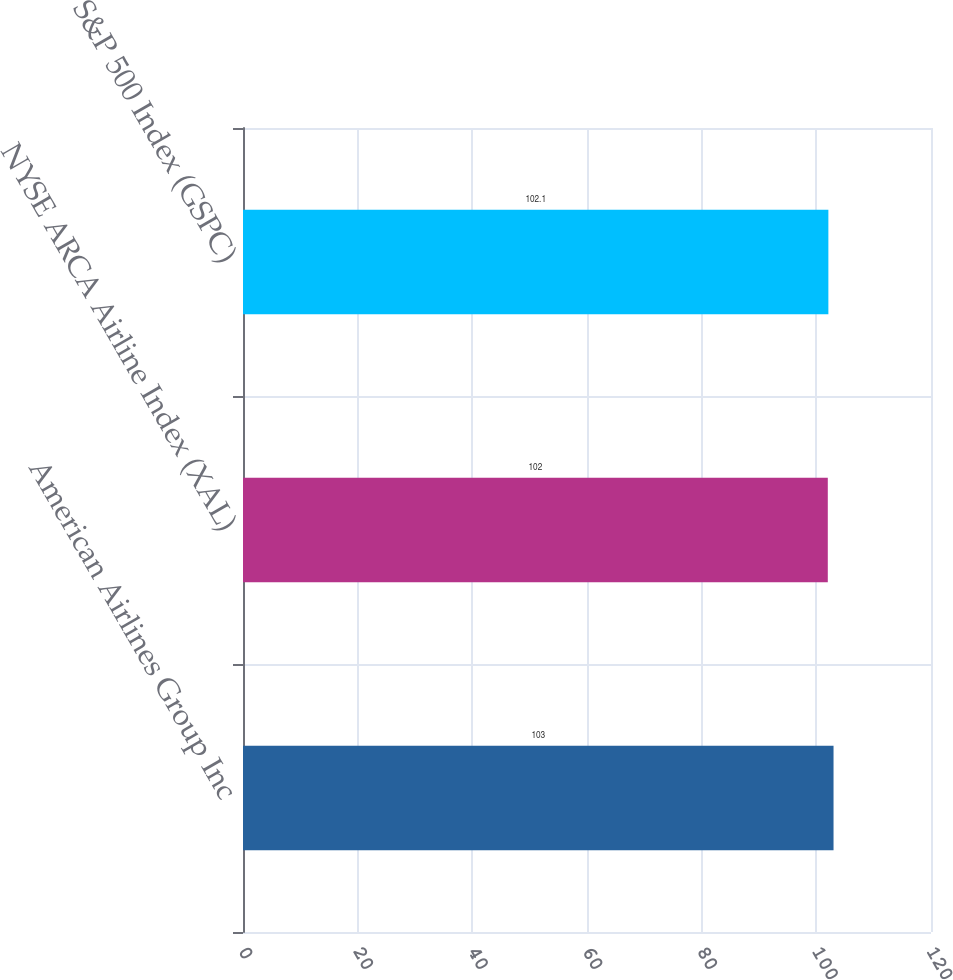Convert chart. <chart><loc_0><loc_0><loc_500><loc_500><bar_chart><fcel>American Airlines Group Inc<fcel>NYSE ARCA Airline Index (XAL)<fcel>S&P 500 Index (GSPC)<nl><fcel>103<fcel>102<fcel>102.1<nl></chart> 